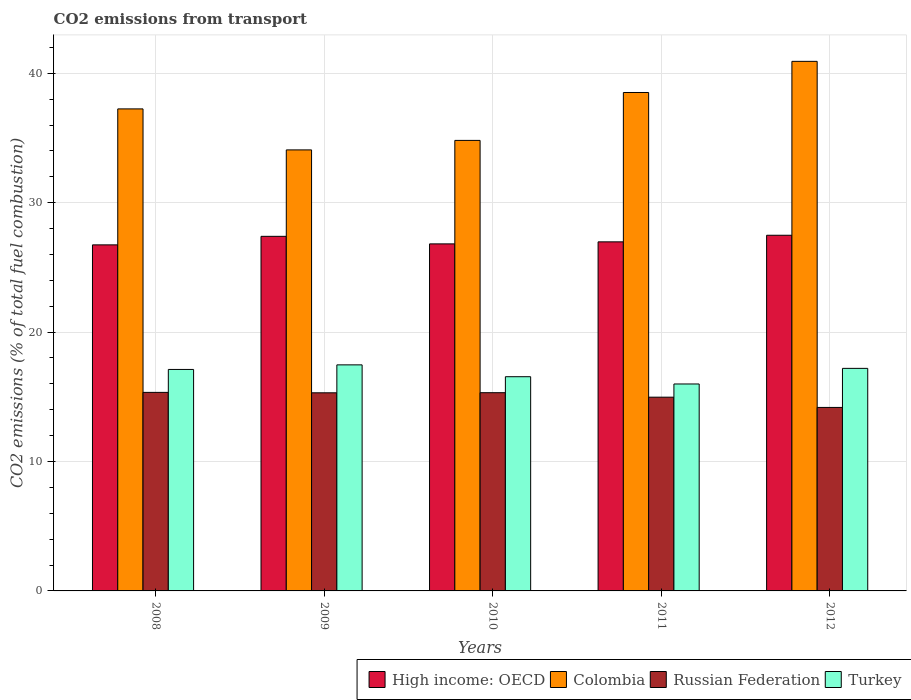Are the number of bars on each tick of the X-axis equal?
Your answer should be very brief. Yes. How many bars are there on the 4th tick from the right?
Offer a terse response. 4. In how many cases, is the number of bars for a given year not equal to the number of legend labels?
Keep it short and to the point. 0. What is the total CO2 emitted in Russian Federation in 2009?
Give a very brief answer. 15.31. Across all years, what is the maximum total CO2 emitted in Colombia?
Provide a succinct answer. 40.92. Across all years, what is the minimum total CO2 emitted in Colombia?
Offer a terse response. 34.08. In which year was the total CO2 emitted in Colombia maximum?
Provide a short and direct response. 2012. What is the total total CO2 emitted in Russian Federation in the graph?
Provide a short and direct response. 75.12. What is the difference between the total CO2 emitted in High income: OECD in 2010 and that in 2011?
Offer a very short reply. -0.16. What is the difference between the total CO2 emitted in Turkey in 2008 and the total CO2 emitted in Russian Federation in 2009?
Provide a short and direct response. 1.81. What is the average total CO2 emitted in Turkey per year?
Your answer should be very brief. 16.86. In the year 2010, what is the difference between the total CO2 emitted in Russian Federation and total CO2 emitted in Turkey?
Keep it short and to the point. -1.24. What is the ratio of the total CO2 emitted in High income: OECD in 2008 to that in 2012?
Offer a terse response. 0.97. Is the difference between the total CO2 emitted in Russian Federation in 2010 and 2011 greater than the difference between the total CO2 emitted in Turkey in 2010 and 2011?
Keep it short and to the point. No. What is the difference between the highest and the second highest total CO2 emitted in Russian Federation?
Keep it short and to the point. 0.03. What is the difference between the highest and the lowest total CO2 emitted in Russian Federation?
Your answer should be very brief. 1.16. In how many years, is the total CO2 emitted in Russian Federation greater than the average total CO2 emitted in Russian Federation taken over all years?
Ensure brevity in your answer.  3. Is it the case that in every year, the sum of the total CO2 emitted in Turkey and total CO2 emitted in Russian Federation is greater than the sum of total CO2 emitted in High income: OECD and total CO2 emitted in Colombia?
Provide a short and direct response. No. What does the 1st bar from the left in 2011 represents?
Keep it short and to the point. High income: OECD. What does the 2nd bar from the right in 2009 represents?
Your answer should be very brief. Russian Federation. Is it the case that in every year, the sum of the total CO2 emitted in High income: OECD and total CO2 emitted in Turkey is greater than the total CO2 emitted in Colombia?
Give a very brief answer. Yes. How many years are there in the graph?
Your answer should be compact. 5. What is the difference between two consecutive major ticks on the Y-axis?
Your answer should be very brief. 10. Are the values on the major ticks of Y-axis written in scientific E-notation?
Your answer should be compact. No. Does the graph contain grids?
Provide a short and direct response. Yes. Where does the legend appear in the graph?
Offer a terse response. Bottom right. How many legend labels are there?
Your answer should be very brief. 4. What is the title of the graph?
Provide a short and direct response. CO2 emissions from transport. Does "Antigua and Barbuda" appear as one of the legend labels in the graph?
Offer a terse response. No. What is the label or title of the Y-axis?
Provide a succinct answer. CO2 emissions (% of total fuel combustion). What is the CO2 emissions (% of total fuel combustion) in High income: OECD in 2008?
Provide a succinct answer. 26.74. What is the CO2 emissions (% of total fuel combustion) of Colombia in 2008?
Your answer should be compact. 37.25. What is the CO2 emissions (% of total fuel combustion) in Russian Federation in 2008?
Your answer should be compact. 15.34. What is the CO2 emissions (% of total fuel combustion) in Turkey in 2008?
Give a very brief answer. 17.11. What is the CO2 emissions (% of total fuel combustion) in High income: OECD in 2009?
Keep it short and to the point. 27.4. What is the CO2 emissions (% of total fuel combustion) in Colombia in 2009?
Give a very brief answer. 34.08. What is the CO2 emissions (% of total fuel combustion) of Russian Federation in 2009?
Provide a short and direct response. 15.31. What is the CO2 emissions (% of total fuel combustion) of Turkey in 2009?
Make the answer very short. 17.47. What is the CO2 emissions (% of total fuel combustion) in High income: OECD in 2010?
Your answer should be compact. 26.82. What is the CO2 emissions (% of total fuel combustion) in Colombia in 2010?
Provide a short and direct response. 34.81. What is the CO2 emissions (% of total fuel combustion) of Russian Federation in 2010?
Provide a succinct answer. 15.32. What is the CO2 emissions (% of total fuel combustion) in Turkey in 2010?
Offer a very short reply. 16.55. What is the CO2 emissions (% of total fuel combustion) in High income: OECD in 2011?
Your response must be concise. 26.97. What is the CO2 emissions (% of total fuel combustion) in Colombia in 2011?
Your answer should be compact. 38.51. What is the CO2 emissions (% of total fuel combustion) in Russian Federation in 2011?
Give a very brief answer. 14.97. What is the CO2 emissions (% of total fuel combustion) of Turkey in 2011?
Your answer should be compact. 15.99. What is the CO2 emissions (% of total fuel combustion) in High income: OECD in 2012?
Your answer should be compact. 27.48. What is the CO2 emissions (% of total fuel combustion) of Colombia in 2012?
Your answer should be compact. 40.92. What is the CO2 emissions (% of total fuel combustion) of Russian Federation in 2012?
Your answer should be very brief. 14.18. What is the CO2 emissions (% of total fuel combustion) of Turkey in 2012?
Your answer should be compact. 17.2. Across all years, what is the maximum CO2 emissions (% of total fuel combustion) of High income: OECD?
Provide a succinct answer. 27.48. Across all years, what is the maximum CO2 emissions (% of total fuel combustion) in Colombia?
Make the answer very short. 40.92. Across all years, what is the maximum CO2 emissions (% of total fuel combustion) of Russian Federation?
Provide a short and direct response. 15.34. Across all years, what is the maximum CO2 emissions (% of total fuel combustion) of Turkey?
Offer a terse response. 17.47. Across all years, what is the minimum CO2 emissions (% of total fuel combustion) in High income: OECD?
Make the answer very short. 26.74. Across all years, what is the minimum CO2 emissions (% of total fuel combustion) in Colombia?
Offer a terse response. 34.08. Across all years, what is the minimum CO2 emissions (% of total fuel combustion) of Russian Federation?
Make the answer very short. 14.18. Across all years, what is the minimum CO2 emissions (% of total fuel combustion) of Turkey?
Provide a succinct answer. 15.99. What is the total CO2 emissions (% of total fuel combustion) in High income: OECD in the graph?
Provide a succinct answer. 135.41. What is the total CO2 emissions (% of total fuel combustion) of Colombia in the graph?
Your response must be concise. 185.57. What is the total CO2 emissions (% of total fuel combustion) in Russian Federation in the graph?
Make the answer very short. 75.12. What is the total CO2 emissions (% of total fuel combustion) in Turkey in the graph?
Your response must be concise. 84.32. What is the difference between the CO2 emissions (% of total fuel combustion) in High income: OECD in 2008 and that in 2009?
Offer a terse response. -0.66. What is the difference between the CO2 emissions (% of total fuel combustion) of Colombia in 2008 and that in 2009?
Provide a short and direct response. 3.17. What is the difference between the CO2 emissions (% of total fuel combustion) in Russian Federation in 2008 and that in 2009?
Give a very brief answer. 0.03. What is the difference between the CO2 emissions (% of total fuel combustion) in Turkey in 2008 and that in 2009?
Ensure brevity in your answer.  -0.35. What is the difference between the CO2 emissions (% of total fuel combustion) in High income: OECD in 2008 and that in 2010?
Your answer should be very brief. -0.08. What is the difference between the CO2 emissions (% of total fuel combustion) in Colombia in 2008 and that in 2010?
Provide a short and direct response. 2.43. What is the difference between the CO2 emissions (% of total fuel combustion) in Russian Federation in 2008 and that in 2010?
Your response must be concise. 0.03. What is the difference between the CO2 emissions (% of total fuel combustion) of Turkey in 2008 and that in 2010?
Make the answer very short. 0.56. What is the difference between the CO2 emissions (% of total fuel combustion) in High income: OECD in 2008 and that in 2011?
Give a very brief answer. -0.23. What is the difference between the CO2 emissions (% of total fuel combustion) of Colombia in 2008 and that in 2011?
Ensure brevity in your answer.  -1.27. What is the difference between the CO2 emissions (% of total fuel combustion) of Russian Federation in 2008 and that in 2011?
Offer a very short reply. 0.37. What is the difference between the CO2 emissions (% of total fuel combustion) of Turkey in 2008 and that in 2011?
Offer a very short reply. 1.12. What is the difference between the CO2 emissions (% of total fuel combustion) in High income: OECD in 2008 and that in 2012?
Offer a terse response. -0.74. What is the difference between the CO2 emissions (% of total fuel combustion) in Colombia in 2008 and that in 2012?
Provide a short and direct response. -3.67. What is the difference between the CO2 emissions (% of total fuel combustion) in Russian Federation in 2008 and that in 2012?
Provide a succinct answer. 1.16. What is the difference between the CO2 emissions (% of total fuel combustion) of Turkey in 2008 and that in 2012?
Make the answer very short. -0.08. What is the difference between the CO2 emissions (% of total fuel combustion) in High income: OECD in 2009 and that in 2010?
Provide a short and direct response. 0.58. What is the difference between the CO2 emissions (% of total fuel combustion) of Colombia in 2009 and that in 2010?
Offer a terse response. -0.73. What is the difference between the CO2 emissions (% of total fuel combustion) in Russian Federation in 2009 and that in 2010?
Ensure brevity in your answer.  -0.01. What is the difference between the CO2 emissions (% of total fuel combustion) in Turkey in 2009 and that in 2010?
Provide a short and direct response. 0.91. What is the difference between the CO2 emissions (% of total fuel combustion) in High income: OECD in 2009 and that in 2011?
Offer a terse response. 0.43. What is the difference between the CO2 emissions (% of total fuel combustion) in Colombia in 2009 and that in 2011?
Provide a short and direct response. -4.44. What is the difference between the CO2 emissions (% of total fuel combustion) of Russian Federation in 2009 and that in 2011?
Offer a terse response. 0.34. What is the difference between the CO2 emissions (% of total fuel combustion) in Turkey in 2009 and that in 2011?
Your answer should be very brief. 1.48. What is the difference between the CO2 emissions (% of total fuel combustion) of High income: OECD in 2009 and that in 2012?
Keep it short and to the point. -0.08. What is the difference between the CO2 emissions (% of total fuel combustion) of Colombia in 2009 and that in 2012?
Provide a short and direct response. -6.84. What is the difference between the CO2 emissions (% of total fuel combustion) of Russian Federation in 2009 and that in 2012?
Give a very brief answer. 1.13. What is the difference between the CO2 emissions (% of total fuel combustion) in Turkey in 2009 and that in 2012?
Give a very brief answer. 0.27. What is the difference between the CO2 emissions (% of total fuel combustion) in High income: OECD in 2010 and that in 2011?
Offer a terse response. -0.16. What is the difference between the CO2 emissions (% of total fuel combustion) in Colombia in 2010 and that in 2011?
Offer a terse response. -3.7. What is the difference between the CO2 emissions (% of total fuel combustion) of Russian Federation in 2010 and that in 2011?
Provide a succinct answer. 0.35. What is the difference between the CO2 emissions (% of total fuel combustion) of Turkey in 2010 and that in 2011?
Offer a very short reply. 0.56. What is the difference between the CO2 emissions (% of total fuel combustion) in High income: OECD in 2010 and that in 2012?
Make the answer very short. -0.67. What is the difference between the CO2 emissions (% of total fuel combustion) of Colombia in 2010 and that in 2012?
Make the answer very short. -6.11. What is the difference between the CO2 emissions (% of total fuel combustion) in Russian Federation in 2010 and that in 2012?
Offer a very short reply. 1.14. What is the difference between the CO2 emissions (% of total fuel combustion) in Turkey in 2010 and that in 2012?
Offer a terse response. -0.64. What is the difference between the CO2 emissions (% of total fuel combustion) of High income: OECD in 2011 and that in 2012?
Give a very brief answer. -0.51. What is the difference between the CO2 emissions (% of total fuel combustion) in Colombia in 2011 and that in 2012?
Give a very brief answer. -2.41. What is the difference between the CO2 emissions (% of total fuel combustion) of Russian Federation in 2011 and that in 2012?
Offer a very short reply. 0.79. What is the difference between the CO2 emissions (% of total fuel combustion) of Turkey in 2011 and that in 2012?
Keep it short and to the point. -1.21. What is the difference between the CO2 emissions (% of total fuel combustion) in High income: OECD in 2008 and the CO2 emissions (% of total fuel combustion) in Colombia in 2009?
Ensure brevity in your answer.  -7.34. What is the difference between the CO2 emissions (% of total fuel combustion) in High income: OECD in 2008 and the CO2 emissions (% of total fuel combustion) in Russian Federation in 2009?
Keep it short and to the point. 11.43. What is the difference between the CO2 emissions (% of total fuel combustion) of High income: OECD in 2008 and the CO2 emissions (% of total fuel combustion) of Turkey in 2009?
Ensure brevity in your answer.  9.27. What is the difference between the CO2 emissions (% of total fuel combustion) of Colombia in 2008 and the CO2 emissions (% of total fuel combustion) of Russian Federation in 2009?
Provide a short and direct response. 21.94. What is the difference between the CO2 emissions (% of total fuel combustion) of Colombia in 2008 and the CO2 emissions (% of total fuel combustion) of Turkey in 2009?
Your answer should be very brief. 19.78. What is the difference between the CO2 emissions (% of total fuel combustion) of Russian Federation in 2008 and the CO2 emissions (% of total fuel combustion) of Turkey in 2009?
Your answer should be compact. -2.13. What is the difference between the CO2 emissions (% of total fuel combustion) of High income: OECD in 2008 and the CO2 emissions (% of total fuel combustion) of Colombia in 2010?
Provide a short and direct response. -8.07. What is the difference between the CO2 emissions (% of total fuel combustion) of High income: OECD in 2008 and the CO2 emissions (% of total fuel combustion) of Russian Federation in 2010?
Ensure brevity in your answer.  11.42. What is the difference between the CO2 emissions (% of total fuel combustion) in High income: OECD in 2008 and the CO2 emissions (% of total fuel combustion) in Turkey in 2010?
Your answer should be compact. 10.19. What is the difference between the CO2 emissions (% of total fuel combustion) of Colombia in 2008 and the CO2 emissions (% of total fuel combustion) of Russian Federation in 2010?
Your answer should be very brief. 21.93. What is the difference between the CO2 emissions (% of total fuel combustion) of Colombia in 2008 and the CO2 emissions (% of total fuel combustion) of Turkey in 2010?
Offer a terse response. 20.69. What is the difference between the CO2 emissions (% of total fuel combustion) of Russian Federation in 2008 and the CO2 emissions (% of total fuel combustion) of Turkey in 2010?
Your answer should be very brief. -1.21. What is the difference between the CO2 emissions (% of total fuel combustion) in High income: OECD in 2008 and the CO2 emissions (% of total fuel combustion) in Colombia in 2011?
Provide a succinct answer. -11.78. What is the difference between the CO2 emissions (% of total fuel combustion) of High income: OECD in 2008 and the CO2 emissions (% of total fuel combustion) of Russian Federation in 2011?
Your answer should be compact. 11.77. What is the difference between the CO2 emissions (% of total fuel combustion) in High income: OECD in 2008 and the CO2 emissions (% of total fuel combustion) in Turkey in 2011?
Keep it short and to the point. 10.75. What is the difference between the CO2 emissions (% of total fuel combustion) of Colombia in 2008 and the CO2 emissions (% of total fuel combustion) of Russian Federation in 2011?
Offer a terse response. 22.28. What is the difference between the CO2 emissions (% of total fuel combustion) of Colombia in 2008 and the CO2 emissions (% of total fuel combustion) of Turkey in 2011?
Provide a succinct answer. 21.26. What is the difference between the CO2 emissions (% of total fuel combustion) of Russian Federation in 2008 and the CO2 emissions (% of total fuel combustion) of Turkey in 2011?
Give a very brief answer. -0.65. What is the difference between the CO2 emissions (% of total fuel combustion) in High income: OECD in 2008 and the CO2 emissions (% of total fuel combustion) in Colombia in 2012?
Keep it short and to the point. -14.18. What is the difference between the CO2 emissions (% of total fuel combustion) of High income: OECD in 2008 and the CO2 emissions (% of total fuel combustion) of Russian Federation in 2012?
Your answer should be very brief. 12.56. What is the difference between the CO2 emissions (% of total fuel combustion) in High income: OECD in 2008 and the CO2 emissions (% of total fuel combustion) in Turkey in 2012?
Offer a very short reply. 9.54. What is the difference between the CO2 emissions (% of total fuel combustion) of Colombia in 2008 and the CO2 emissions (% of total fuel combustion) of Russian Federation in 2012?
Ensure brevity in your answer.  23.07. What is the difference between the CO2 emissions (% of total fuel combustion) in Colombia in 2008 and the CO2 emissions (% of total fuel combustion) in Turkey in 2012?
Keep it short and to the point. 20.05. What is the difference between the CO2 emissions (% of total fuel combustion) in Russian Federation in 2008 and the CO2 emissions (% of total fuel combustion) in Turkey in 2012?
Provide a short and direct response. -1.86. What is the difference between the CO2 emissions (% of total fuel combustion) in High income: OECD in 2009 and the CO2 emissions (% of total fuel combustion) in Colombia in 2010?
Make the answer very short. -7.41. What is the difference between the CO2 emissions (% of total fuel combustion) of High income: OECD in 2009 and the CO2 emissions (% of total fuel combustion) of Russian Federation in 2010?
Give a very brief answer. 12.08. What is the difference between the CO2 emissions (% of total fuel combustion) of High income: OECD in 2009 and the CO2 emissions (% of total fuel combustion) of Turkey in 2010?
Provide a succinct answer. 10.85. What is the difference between the CO2 emissions (% of total fuel combustion) of Colombia in 2009 and the CO2 emissions (% of total fuel combustion) of Russian Federation in 2010?
Your answer should be very brief. 18.76. What is the difference between the CO2 emissions (% of total fuel combustion) in Colombia in 2009 and the CO2 emissions (% of total fuel combustion) in Turkey in 2010?
Provide a succinct answer. 17.53. What is the difference between the CO2 emissions (% of total fuel combustion) in Russian Federation in 2009 and the CO2 emissions (% of total fuel combustion) in Turkey in 2010?
Offer a very short reply. -1.24. What is the difference between the CO2 emissions (% of total fuel combustion) of High income: OECD in 2009 and the CO2 emissions (% of total fuel combustion) of Colombia in 2011?
Provide a short and direct response. -11.12. What is the difference between the CO2 emissions (% of total fuel combustion) in High income: OECD in 2009 and the CO2 emissions (% of total fuel combustion) in Russian Federation in 2011?
Offer a terse response. 12.43. What is the difference between the CO2 emissions (% of total fuel combustion) of High income: OECD in 2009 and the CO2 emissions (% of total fuel combustion) of Turkey in 2011?
Provide a succinct answer. 11.41. What is the difference between the CO2 emissions (% of total fuel combustion) of Colombia in 2009 and the CO2 emissions (% of total fuel combustion) of Russian Federation in 2011?
Offer a very short reply. 19.11. What is the difference between the CO2 emissions (% of total fuel combustion) in Colombia in 2009 and the CO2 emissions (% of total fuel combustion) in Turkey in 2011?
Your response must be concise. 18.09. What is the difference between the CO2 emissions (% of total fuel combustion) of Russian Federation in 2009 and the CO2 emissions (% of total fuel combustion) of Turkey in 2011?
Offer a very short reply. -0.68. What is the difference between the CO2 emissions (% of total fuel combustion) of High income: OECD in 2009 and the CO2 emissions (% of total fuel combustion) of Colombia in 2012?
Give a very brief answer. -13.52. What is the difference between the CO2 emissions (% of total fuel combustion) of High income: OECD in 2009 and the CO2 emissions (% of total fuel combustion) of Russian Federation in 2012?
Your answer should be very brief. 13.22. What is the difference between the CO2 emissions (% of total fuel combustion) in High income: OECD in 2009 and the CO2 emissions (% of total fuel combustion) in Turkey in 2012?
Offer a terse response. 10.2. What is the difference between the CO2 emissions (% of total fuel combustion) in Colombia in 2009 and the CO2 emissions (% of total fuel combustion) in Russian Federation in 2012?
Your response must be concise. 19.9. What is the difference between the CO2 emissions (% of total fuel combustion) in Colombia in 2009 and the CO2 emissions (% of total fuel combustion) in Turkey in 2012?
Your answer should be compact. 16.88. What is the difference between the CO2 emissions (% of total fuel combustion) of Russian Federation in 2009 and the CO2 emissions (% of total fuel combustion) of Turkey in 2012?
Offer a terse response. -1.89. What is the difference between the CO2 emissions (% of total fuel combustion) of High income: OECD in 2010 and the CO2 emissions (% of total fuel combustion) of Colombia in 2011?
Provide a succinct answer. -11.7. What is the difference between the CO2 emissions (% of total fuel combustion) in High income: OECD in 2010 and the CO2 emissions (% of total fuel combustion) in Russian Federation in 2011?
Your answer should be very brief. 11.84. What is the difference between the CO2 emissions (% of total fuel combustion) in High income: OECD in 2010 and the CO2 emissions (% of total fuel combustion) in Turkey in 2011?
Keep it short and to the point. 10.83. What is the difference between the CO2 emissions (% of total fuel combustion) of Colombia in 2010 and the CO2 emissions (% of total fuel combustion) of Russian Federation in 2011?
Offer a very short reply. 19.84. What is the difference between the CO2 emissions (% of total fuel combustion) of Colombia in 2010 and the CO2 emissions (% of total fuel combustion) of Turkey in 2011?
Provide a succinct answer. 18.82. What is the difference between the CO2 emissions (% of total fuel combustion) of Russian Federation in 2010 and the CO2 emissions (% of total fuel combustion) of Turkey in 2011?
Your answer should be compact. -0.67. What is the difference between the CO2 emissions (% of total fuel combustion) in High income: OECD in 2010 and the CO2 emissions (% of total fuel combustion) in Colombia in 2012?
Ensure brevity in your answer.  -14.1. What is the difference between the CO2 emissions (% of total fuel combustion) of High income: OECD in 2010 and the CO2 emissions (% of total fuel combustion) of Russian Federation in 2012?
Make the answer very short. 12.64. What is the difference between the CO2 emissions (% of total fuel combustion) in High income: OECD in 2010 and the CO2 emissions (% of total fuel combustion) in Turkey in 2012?
Your answer should be compact. 9.62. What is the difference between the CO2 emissions (% of total fuel combustion) of Colombia in 2010 and the CO2 emissions (% of total fuel combustion) of Russian Federation in 2012?
Your answer should be very brief. 20.63. What is the difference between the CO2 emissions (% of total fuel combustion) in Colombia in 2010 and the CO2 emissions (% of total fuel combustion) in Turkey in 2012?
Give a very brief answer. 17.62. What is the difference between the CO2 emissions (% of total fuel combustion) in Russian Federation in 2010 and the CO2 emissions (% of total fuel combustion) in Turkey in 2012?
Your answer should be very brief. -1.88. What is the difference between the CO2 emissions (% of total fuel combustion) in High income: OECD in 2011 and the CO2 emissions (% of total fuel combustion) in Colombia in 2012?
Give a very brief answer. -13.95. What is the difference between the CO2 emissions (% of total fuel combustion) of High income: OECD in 2011 and the CO2 emissions (% of total fuel combustion) of Russian Federation in 2012?
Keep it short and to the point. 12.8. What is the difference between the CO2 emissions (% of total fuel combustion) in High income: OECD in 2011 and the CO2 emissions (% of total fuel combustion) in Turkey in 2012?
Keep it short and to the point. 9.78. What is the difference between the CO2 emissions (% of total fuel combustion) of Colombia in 2011 and the CO2 emissions (% of total fuel combustion) of Russian Federation in 2012?
Offer a terse response. 24.34. What is the difference between the CO2 emissions (% of total fuel combustion) of Colombia in 2011 and the CO2 emissions (% of total fuel combustion) of Turkey in 2012?
Provide a short and direct response. 21.32. What is the difference between the CO2 emissions (% of total fuel combustion) in Russian Federation in 2011 and the CO2 emissions (% of total fuel combustion) in Turkey in 2012?
Ensure brevity in your answer.  -2.23. What is the average CO2 emissions (% of total fuel combustion) of High income: OECD per year?
Ensure brevity in your answer.  27.08. What is the average CO2 emissions (% of total fuel combustion) of Colombia per year?
Ensure brevity in your answer.  37.11. What is the average CO2 emissions (% of total fuel combustion) in Russian Federation per year?
Make the answer very short. 15.02. What is the average CO2 emissions (% of total fuel combustion) of Turkey per year?
Offer a very short reply. 16.86. In the year 2008, what is the difference between the CO2 emissions (% of total fuel combustion) of High income: OECD and CO2 emissions (% of total fuel combustion) of Colombia?
Offer a very short reply. -10.51. In the year 2008, what is the difference between the CO2 emissions (% of total fuel combustion) of High income: OECD and CO2 emissions (% of total fuel combustion) of Russian Federation?
Your answer should be very brief. 11.4. In the year 2008, what is the difference between the CO2 emissions (% of total fuel combustion) in High income: OECD and CO2 emissions (% of total fuel combustion) in Turkey?
Your answer should be compact. 9.63. In the year 2008, what is the difference between the CO2 emissions (% of total fuel combustion) of Colombia and CO2 emissions (% of total fuel combustion) of Russian Federation?
Your answer should be compact. 21.91. In the year 2008, what is the difference between the CO2 emissions (% of total fuel combustion) of Colombia and CO2 emissions (% of total fuel combustion) of Turkey?
Your answer should be compact. 20.13. In the year 2008, what is the difference between the CO2 emissions (% of total fuel combustion) of Russian Federation and CO2 emissions (% of total fuel combustion) of Turkey?
Provide a short and direct response. -1.77. In the year 2009, what is the difference between the CO2 emissions (% of total fuel combustion) of High income: OECD and CO2 emissions (% of total fuel combustion) of Colombia?
Provide a short and direct response. -6.68. In the year 2009, what is the difference between the CO2 emissions (% of total fuel combustion) in High income: OECD and CO2 emissions (% of total fuel combustion) in Russian Federation?
Give a very brief answer. 12.09. In the year 2009, what is the difference between the CO2 emissions (% of total fuel combustion) of High income: OECD and CO2 emissions (% of total fuel combustion) of Turkey?
Keep it short and to the point. 9.93. In the year 2009, what is the difference between the CO2 emissions (% of total fuel combustion) of Colombia and CO2 emissions (% of total fuel combustion) of Russian Federation?
Give a very brief answer. 18.77. In the year 2009, what is the difference between the CO2 emissions (% of total fuel combustion) in Colombia and CO2 emissions (% of total fuel combustion) in Turkey?
Give a very brief answer. 16.61. In the year 2009, what is the difference between the CO2 emissions (% of total fuel combustion) of Russian Federation and CO2 emissions (% of total fuel combustion) of Turkey?
Offer a very short reply. -2.16. In the year 2010, what is the difference between the CO2 emissions (% of total fuel combustion) in High income: OECD and CO2 emissions (% of total fuel combustion) in Colombia?
Offer a terse response. -8. In the year 2010, what is the difference between the CO2 emissions (% of total fuel combustion) in High income: OECD and CO2 emissions (% of total fuel combustion) in Russian Federation?
Provide a succinct answer. 11.5. In the year 2010, what is the difference between the CO2 emissions (% of total fuel combustion) in High income: OECD and CO2 emissions (% of total fuel combustion) in Turkey?
Offer a terse response. 10.26. In the year 2010, what is the difference between the CO2 emissions (% of total fuel combustion) of Colombia and CO2 emissions (% of total fuel combustion) of Russian Federation?
Make the answer very short. 19.5. In the year 2010, what is the difference between the CO2 emissions (% of total fuel combustion) in Colombia and CO2 emissions (% of total fuel combustion) in Turkey?
Keep it short and to the point. 18.26. In the year 2010, what is the difference between the CO2 emissions (% of total fuel combustion) of Russian Federation and CO2 emissions (% of total fuel combustion) of Turkey?
Provide a short and direct response. -1.24. In the year 2011, what is the difference between the CO2 emissions (% of total fuel combustion) of High income: OECD and CO2 emissions (% of total fuel combustion) of Colombia?
Give a very brief answer. -11.54. In the year 2011, what is the difference between the CO2 emissions (% of total fuel combustion) in High income: OECD and CO2 emissions (% of total fuel combustion) in Russian Federation?
Keep it short and to the point. 12. In the year 2011, what is the difference between the CO2 emissions (% of total fuel combustion) of High income: OECD and CO2 emissions (% of total fuel combustion) of Turkey?
Your answer should be compact. 10.98. In the year 2011, what is the difference between the CO2 emissions (% of total fuel combustion) in Colombia and CO2 emissions (% of total fuel combustion) in Russian Federation?
Offer a very short reply. 23.54. In the year 2011, what is the difference between the CO2 emissions (% of total fuel combustion) of Colombia and CO2 emissions (% of total fuel combustion) of Turkey?
Make the answer very short. 22.52. In the year 2011, what is the difference between the CO2 emissions (% of total fuel combustion) in Russian Federation and CO2 emissions (% of total fuel combustion) in Turkey?
Offer a terse response. -1.02. In the year 2012, what is the difference between the CO2 emissions (% of total fuel combustion) of High income: OECD and CO2 emissions (% of total fuel combustion) of Colombia?
Your answer should be very brief. -13.44. In the year 2012, what is the difference between the CO2 emissions (% of total fuel combustion) in High income: OECD and CO2 emissions (% of total fuel combustion) in Russian Federation?
Make the answer very short. 13.3. In the year 2012, what is the difference between the CO2 emissions (% of total fuel combustion) in High income: OECD and CO2 emissions (% of total fuel combustion) in Turkey?
Your answer should be very brief. 10.29. In the year 2012, what is the difference between the CO2 emissions (% of total fuel combustion) of Colombia and CO2 emissions (% of total fuel combustion) of Russian Federation?
Offer a very short reply. 26.74. In the year 2012, what is the difference between the CO2 emissions (% of total fuel combustion) of Colombia and CO2 emissions (% of total fuel combustion) of Turkey?
Offer a very short reply. 23.72. In the year 2012, what is the difference between the CO2 emissions (% of total fuel combustion) of Russian Federation and CO2 emissions (% of total fuel combustion) of Turkey?
Give a very brief answer. -3.02. What is the ratio of the CO2 emissions (% of total fuel combustion) of High income: OECD in 2008 to that in 2009?
Offer a very short reply. 0.98. What is the ratio of the CO2 emissions (% of total fuel combustion) in Colombia in 2008 to that in 2009?
Offer a terse response. 1.09. What is the ratio of the CO2 emissions (% of total fuel combustion) in Turkey in 2008 to that in 2009?
Your answer should be compact. 0.98. What is the ratio of the CO2 emissions (% of total fuel combustion) in High income: OECD in 2008 to that in 2010?
Offer a very short reply. 1. What is the ratio of the CO2 emissions (% of total fuel combustion) in Colombia in 2008 to that in 2010?
Your answer should be very brief. 1.07. What is the ratio of the CO2 emissions (% of total fuel combustion) in Russian Federation in 2008 to that in 2010?
Give a very brief answer. 1. What is the ratio of the CO2 emissions (% of total fuel combustion) of Turkey in 2008 to that in 2010?
Give a very brief answer. 1.03. What is the ratio of the CO2 emissions (% of total fuel combustion) in High income: OECD in 2008 to that in 2011?
Offer a terse response. 0.99. What is the ratio of the CO2 emissions (% of total fuel combustion) of Colombia in 2008 to that in 2011?
Offer a very short reply. 0.97. What is the ratio of the CO2 emissions (% of total fuel combustion) in Russian Federation in 2008 to that in 2011?
Give a very brief answer. 1.02. What is the ratio of the CO2 emissions (% of total fuel combustion) in Turkey in 2008 to that in 2011?
Your response must be concise. 1.07. What is the ratio of the CO2 emissions (% of total fuel combustion) of Colombia in 2008 to that in 2012?
Provide a succinct answer. 0.91. What is the ratio of the CO2 emissions (% of total fuel combustion) in Russian Federation in 2008 to that in 2012?
Provide a succinct answer. 1.08. What is the ratio of the CO2 emissions (% of total fuel combustion) of Turkey in 2008 to that in 2012?
Offer a terse response. 1. What is the ratio of the CO2 emissions (% of total fuel combustion) of High income: OECD in 2009 to that in 2010?
Provide a short and direct response. 1.02. What is the ratio of the CO2 emissions (% of total fuel combustion) of Colombia in 2009 to that in 2010?
Your answer should be very brief. 0.98. What is the ratio of the CO2 emissions (% of total fuel combustion) in Russian Federation in 2009 to that in 2010?
Keep it short and to the point. 1. What is the ratio of the CO2 emissions (% of total fuel combustion) in Turkey in 2009 to that in 2010?
Offer a very short reply. 1.06. What is the ratio of the CO2 emissions (% of total fuel combustion) in High income: OECD in 2009 to that in 2011?
Offer a terse response. 1.02. What is the ratio of the CO2 emissions (% of total fuel combustion) of Colombia in 2009 to that in 2011?
Ensure brevity in your answer.  0.88. What is the ratio of the CO2 emissions (% of total fuel combustion) of Russian Federation in 2009 to that in 2011?
Keep it short and to the point. 1.02. What is the ratio of the CO2 emissions (% of total fuel combustion) in Turkey in 2009 to that in 2011?
Provide a succinct answer. 1.09. What is the ratio of the CO2 emissions (% of total fuel combustion) in High income: OECD in 2009 to that in 2012?
Offer a very short reply. 1. What is the ratio of the CO2 emissions (% of total fuel combustion) of Colombia in 2009 to that in 2012?
Your answer should be very brief. 0.83. What is the ratio of the CO2 emissions (% of total fuel combustion) of Russian Federation in 2009 to that in 2012?
Provide a succinct answer. 1.08. What is the ratio of the CO2 emissions (% of total fuel combustion) of Turkey in 2009 to that in 2012?
Offer a very short reply. 1.02. What is the ratio of the CO2 emissions (% of total fuel combustion) in High income: OECD in 2010 to that in 2011?
Offer a very short reply. 0.99. What is the ratio of the CO2 emissions (% of total fuel combustion) in Colombia in 2010 to that in 2011?
Your response must be concise. 0.9. What is the ratio of the CO2 emissions (% of total fuel combustion) in Russian Federation in 2010 to that in 2011?
Offer a terse response. 1.02. What is the ratio of the CO2 emissions (% of total fuel combustion) in Turkey in 2010 to that in 2011?
Your response must be concise. 1.04. What is the ratio of the CO2 emissions (% of total fuel combustion) in High income: OECD in 2010 to that in 2012?
Your response must be concise. 0.98. What is the ratio of the CO2 emissions (% of total fuel combustion) in Colombia in 2010 to that in 2012?
Ensure brevity in your answer.  0.85. What is the ratio of the CO2 emissions (% of total fuel combustion) of Russian Federation in 2010 to that in 2012?
Provide a short and direct response. 1.08. What is the ratio of the CO2 emissions (% of total fuel combustion) in Turkey in 2010 to that in 2012?
Your answer should be compact. 0.96. What is the ratio of the CO2 emissions (% of total fuel combustion) in High income: OECD in 2011 to that in 2012?
Ensure brevity in your answer.  0.98. What is the ratio of the CO2 emissions (% of total fuel combustion) in Colombia in 2011 to that in 2012?
Keep it short and to the point. 0.94. What is the ratio of the CO2 emissions (% of total fuel combustion) in Russian Federation in 2011 to that in 2012?
Offer a terse response. 1.06. What is the ratio of the CO2 emissions (% of total fuel combustion) in Turkey in 2011 to that in 2012?
Your answer should be very brief. 0.93. What is the difference between the highest and the second highest CO2 emissions (% of total fuel combustion) of High income: OECD?
Offer a terse response. 0.08. What is the difference between the highest and the second highest CO2 emissions (% of total fuel combustion) in Colombia?
Your response must be concise. 2.41. What is the difference between the highest and the second highest CO2 emissions (% of total fuel combustion) of Russian Federation?
Ensure brevity in your answer.  0.03. What is the difference between the highest and the second highest CO2 emissions (% of total fuel combustion) in Turkey?
Ensure brevity in your answer.  0.27. What is the difference between the highest and the lowest CO2 emissions (% of total fuel combustion) of High income: OECD?
Make the answer very short. 0.74. What is the difference between the highest and the lowest CO2 emissions (% of total fuel combustion) in Colombia?
Provide a succinct answer. 6.84. What is the difference between the highest and the lowest CO2 emissions (% of total fuel combustion) in Russian Federation?
Offer a very short reply. 1.16. What is the difference between the highest and the lowest CO2 emissions (% of total fuel combustion) of Turkey?
Offer a terse response. 1.48. 